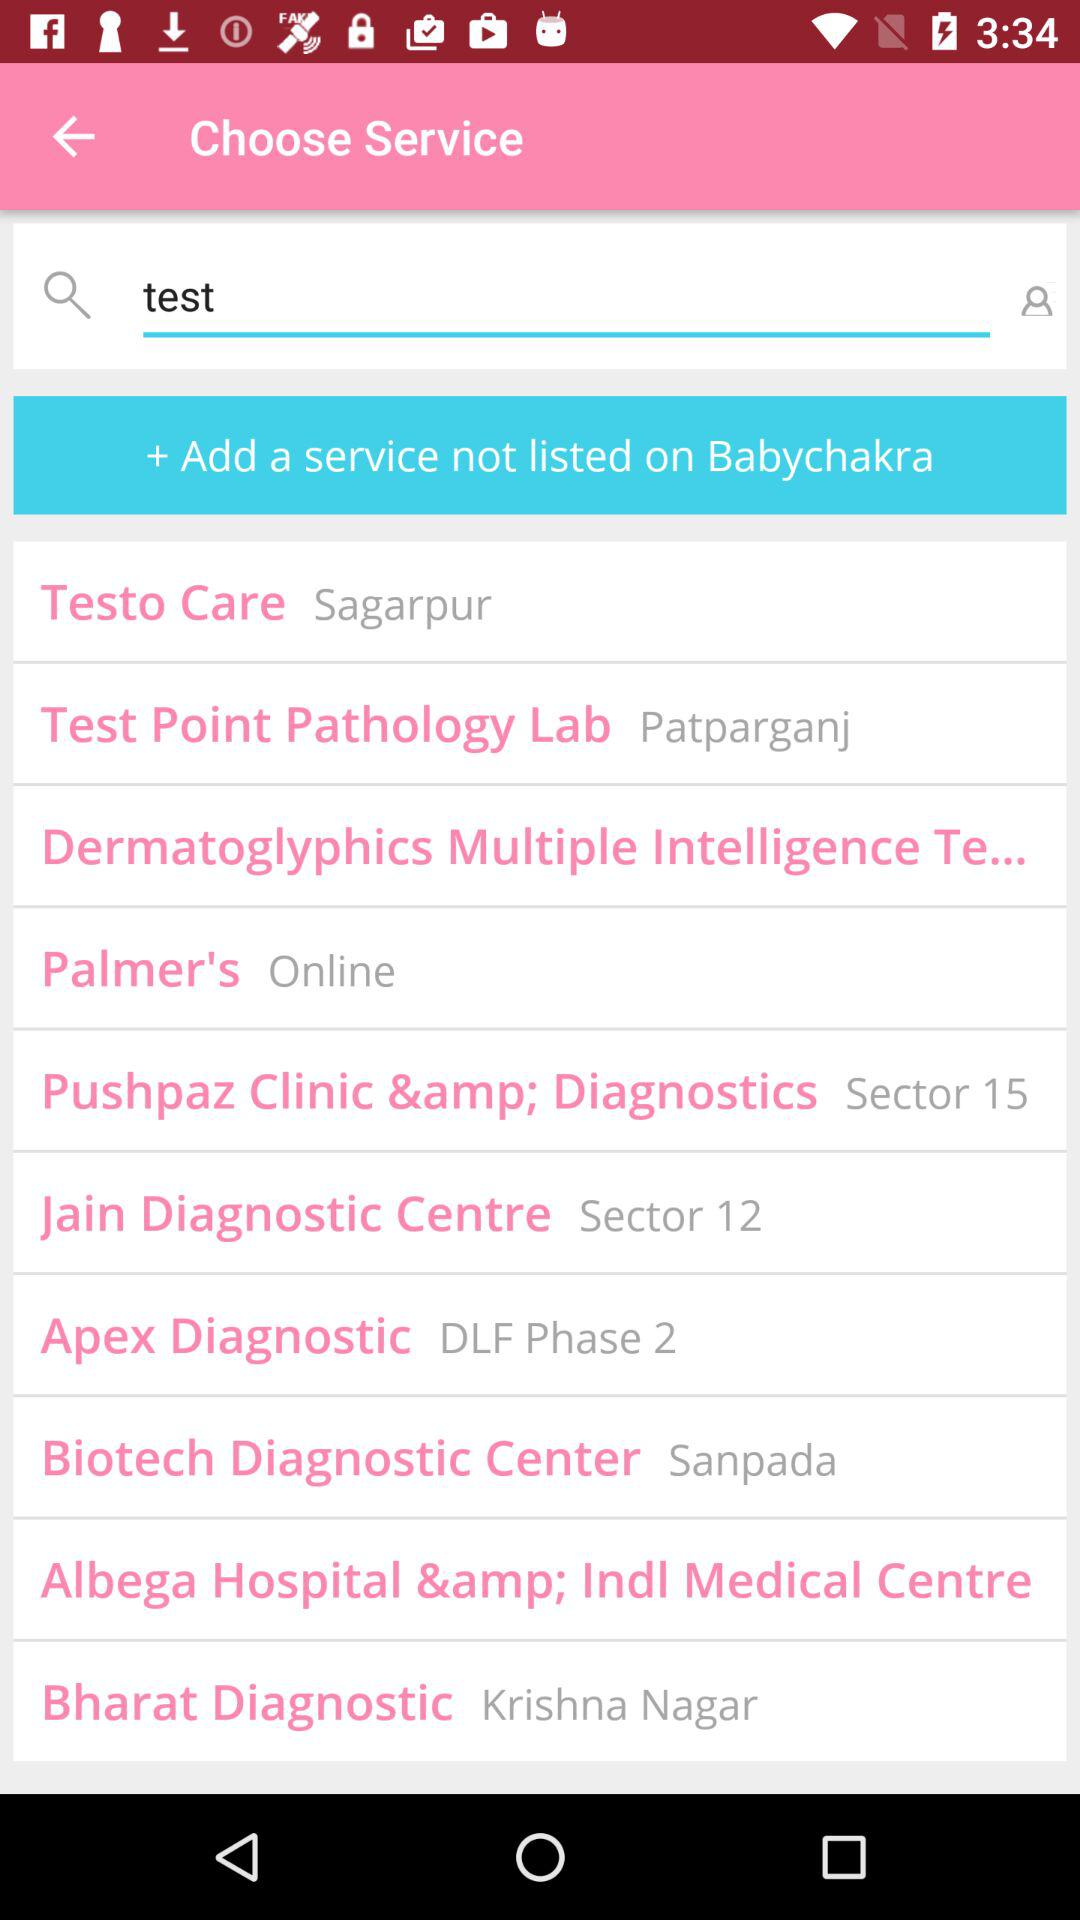How many service providers are located in Sagarpur?
Answer the question using a single word or phrase. 1 